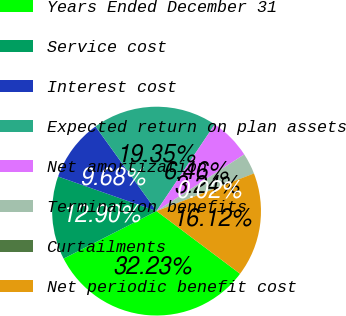<chart> <loc_0><loc_0><loc_500><loc_500><pie_chart><fcel>Years Ended December 31<fcel>Service cost<fcel>Interest cost<fcel>Expected return on plan assets<fcel>Net amortization<fcel>Termination benefits<fcel>Curtailments<fcel>Net periodic benefit cost<nl><fcel>32.23%<fcel>12.9%<fcel>9.68%<fcel>19.35%<fcel>6.46%<fcel>3.24%<fcel>0.02%<fcel>16.12%<nl></chart> 